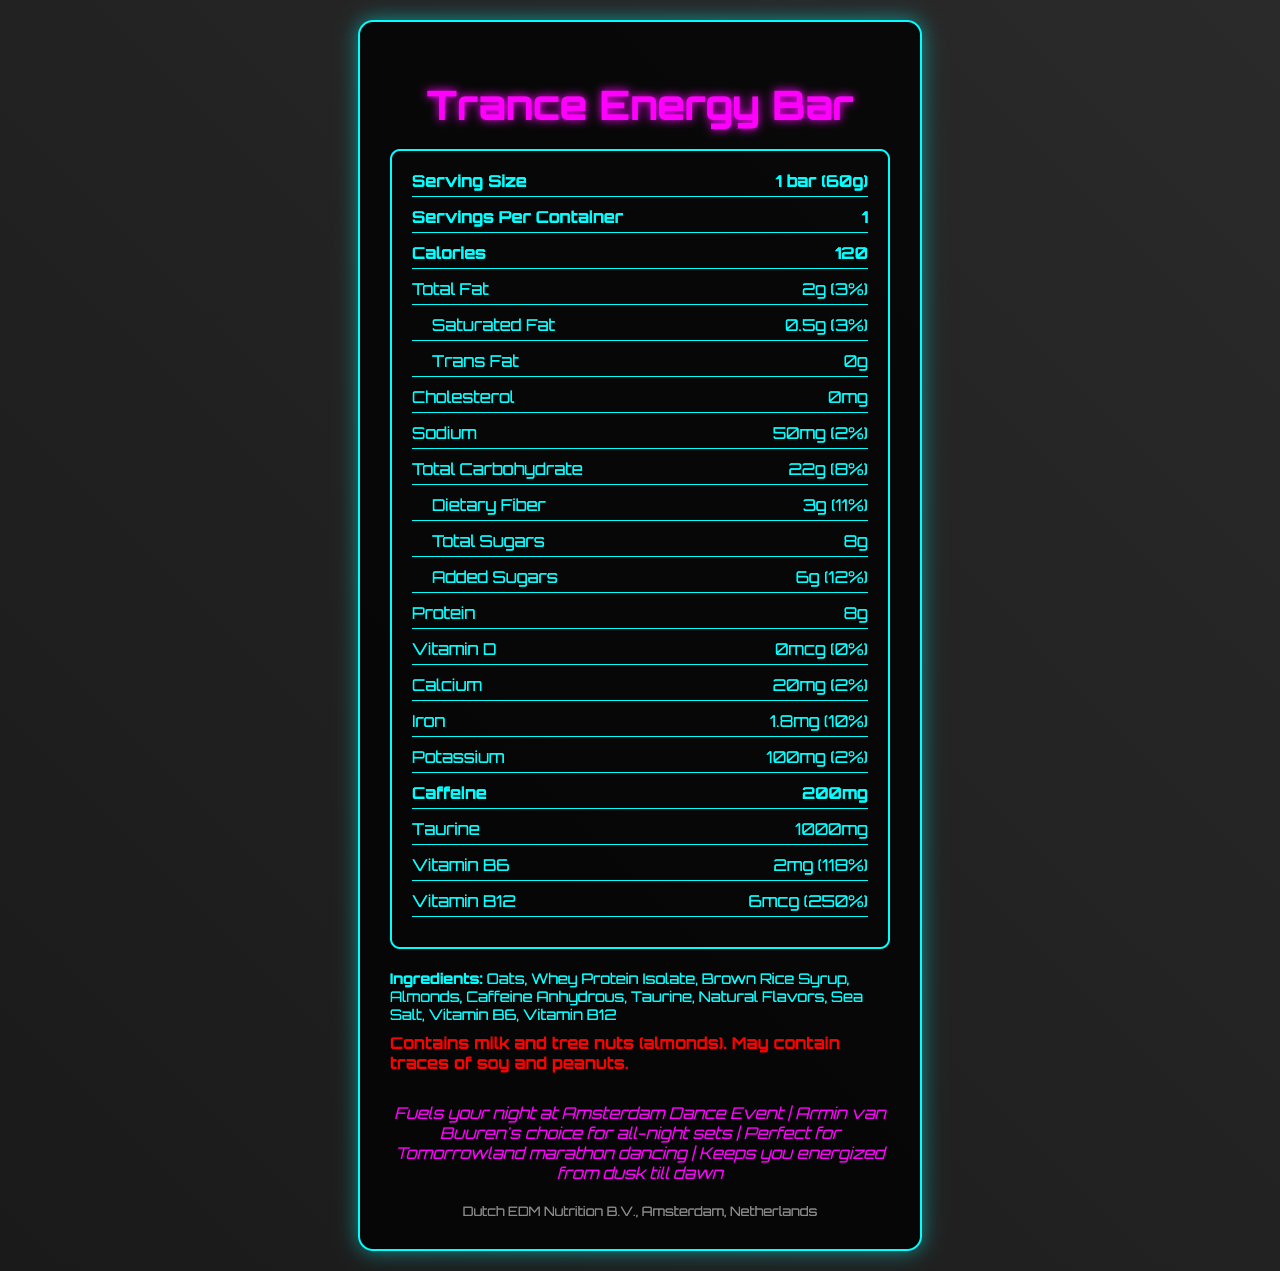what is the product name? The product name is clearly stated at the beginning of the document as "Trance Energy Bar".
Answer: Trance Energy Bar how many calories are in one serving? The nutrition facts label indicates that one serving contains 120 calories.
Answer: 120 what is the serving size? The serving size is mentioned at the top of the nutrition facts label as "1 bar (60g)".
Answer: 1 bar (60g) how much caffeine is in the Trance Energy Bar? The document lists the caffeine content as 200mg.
Answer: 200mg what type of ingredients are used in the bar? The ingredients are detailed under the ingredients section of the document.
Answer: Oats, Whey Protein Isolate, Brown Rice Syrup, Almonds, Caffeine Anhydrous, Taurine, Natural Flavors, Sea Salt, Vitamin B6, Vitamin B12 which nutrient contributes the most to the Daily Value percentage? A. Protein B. Vitamin B6 C. Vitamin B12 D. Iron Vitamin B12 contributes 250% to the Daily Value, which is the highest percentage listed.
Answer: C. Vitamin B12 what marketing claim is associated with Armin van Buuren? A. Fuels your night at Amsterdam Dance Event B. Perfect for Tomorrowland marathon dancing C. Armin van Buuren's choice for all-night sets D. Keeps you energized from dusk till dawn One of the marketing claims specifically mentions Armin van Buuren as “Armin van Buuren's choice for all-night sets”.
Answer: C. Armin van Buuren's choice for all-night sets does the Trance Energy Bar contain cholesterol? The document states that the cholesterol content is 0mg.
Answer: No are there any allergens in the energy bar? According to the document, the bar contains milk and tree nuts (almonds), and may contain traces of soy and peanuts.
Answer: Yes describe the main idea of the document The document outlines the nutritional content and benefits of the Trance Energy Bar, its ingredients, any potential allergens, and the marketing claims that position it as an ideal energy source for music events and all-night performances.
Answer: The document provides detailed information about the Trance Energy Bar, including its nutritional facts, ingredients, allergens, and marketing claims. It is targeted at electronic dance music enthusiasts and emphasizes its suitability for energy during long dancing sessions. how many grams of total fat are in one serving? The total fat content is listed as 2g in the nutrition facts label.
Answer: 2g what is the amount of iron per serving? The document states that each serving contains 1.8mg of iron.
Answer: 1.8mg what percentage of the daily value does calcium contribute? The calcium content in one serving of the Trance Energy Bar contributes 2% to the daily value.
Answer: 2% does the document provide the exact caffeine source in the bar? The document lists "Caffeine Anhydrous" as one of the ingredients, which specifies the source of caffeine.
Answer: Yes what is the total protein content in one bar? The total protein content is listed as 8g in the nutrition facts label.
Answer: 8g how much dietary fiber is in one serving? The dietary fiber content is listed as 3g in the nutrition facts label.
Answer: 3g is there information about the bar's suitability for vegans? The document does not specify whether the bar is suitable for vegans, though it contains whey protein isolate and milk which are typically non-vegan products.
Answer: Not enough information 